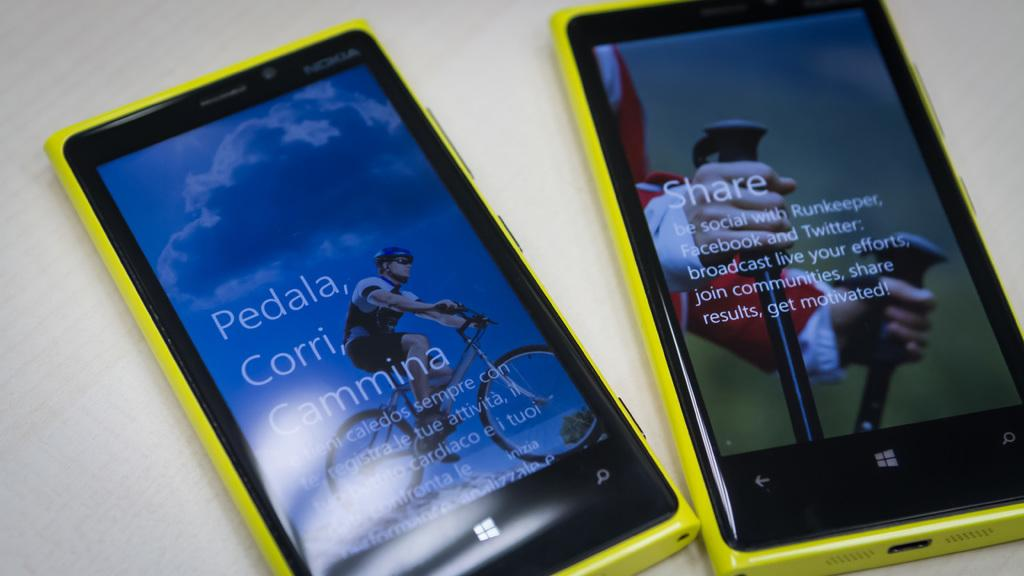<image>
Describe the image concisely. Two yellow windows smart phones, one of which says Share on the screen. 